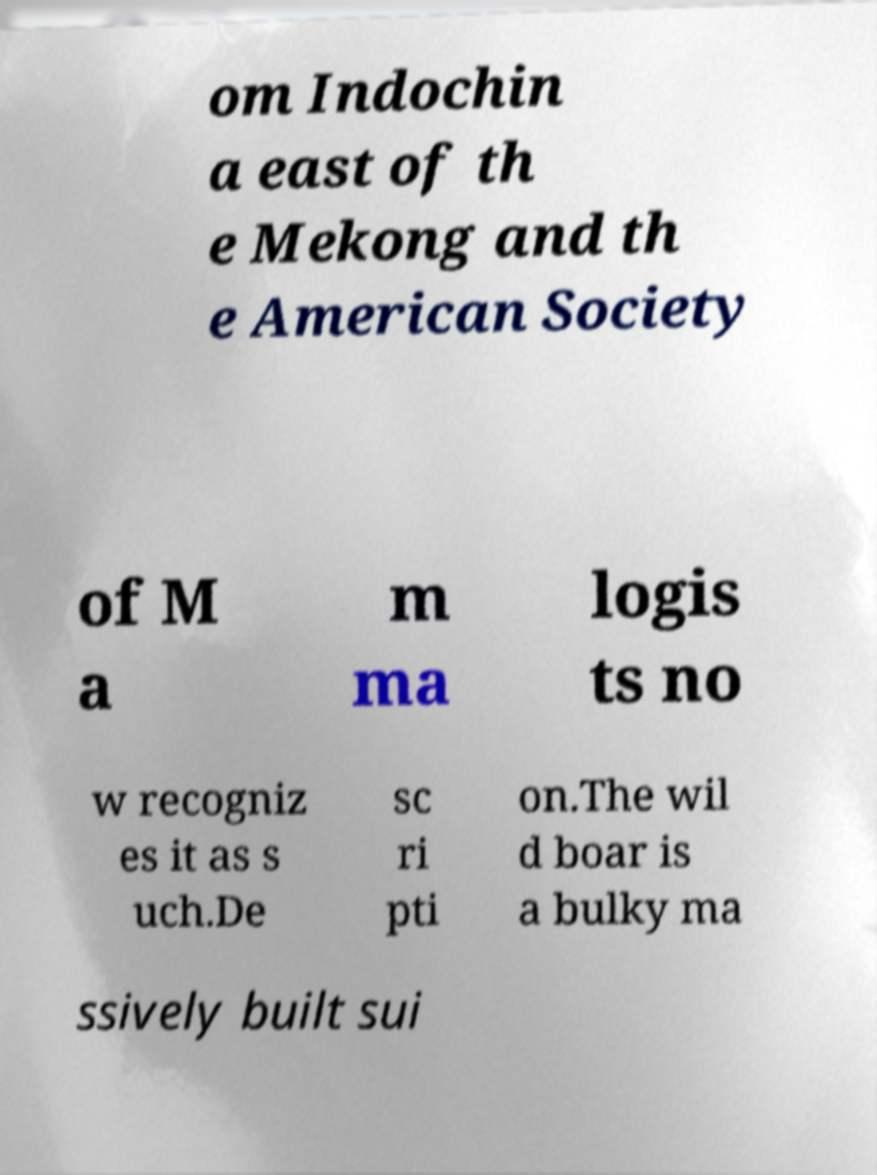For documentation purposes, I need the text within this image transcribed. Could you provide that? om Indochin a east of th e Mekong and th e American Society of M a m ma logis ts no w recogniz es it as s uch.De sc ri pti on.The wil d boar is a bulky ma ssively built sui 